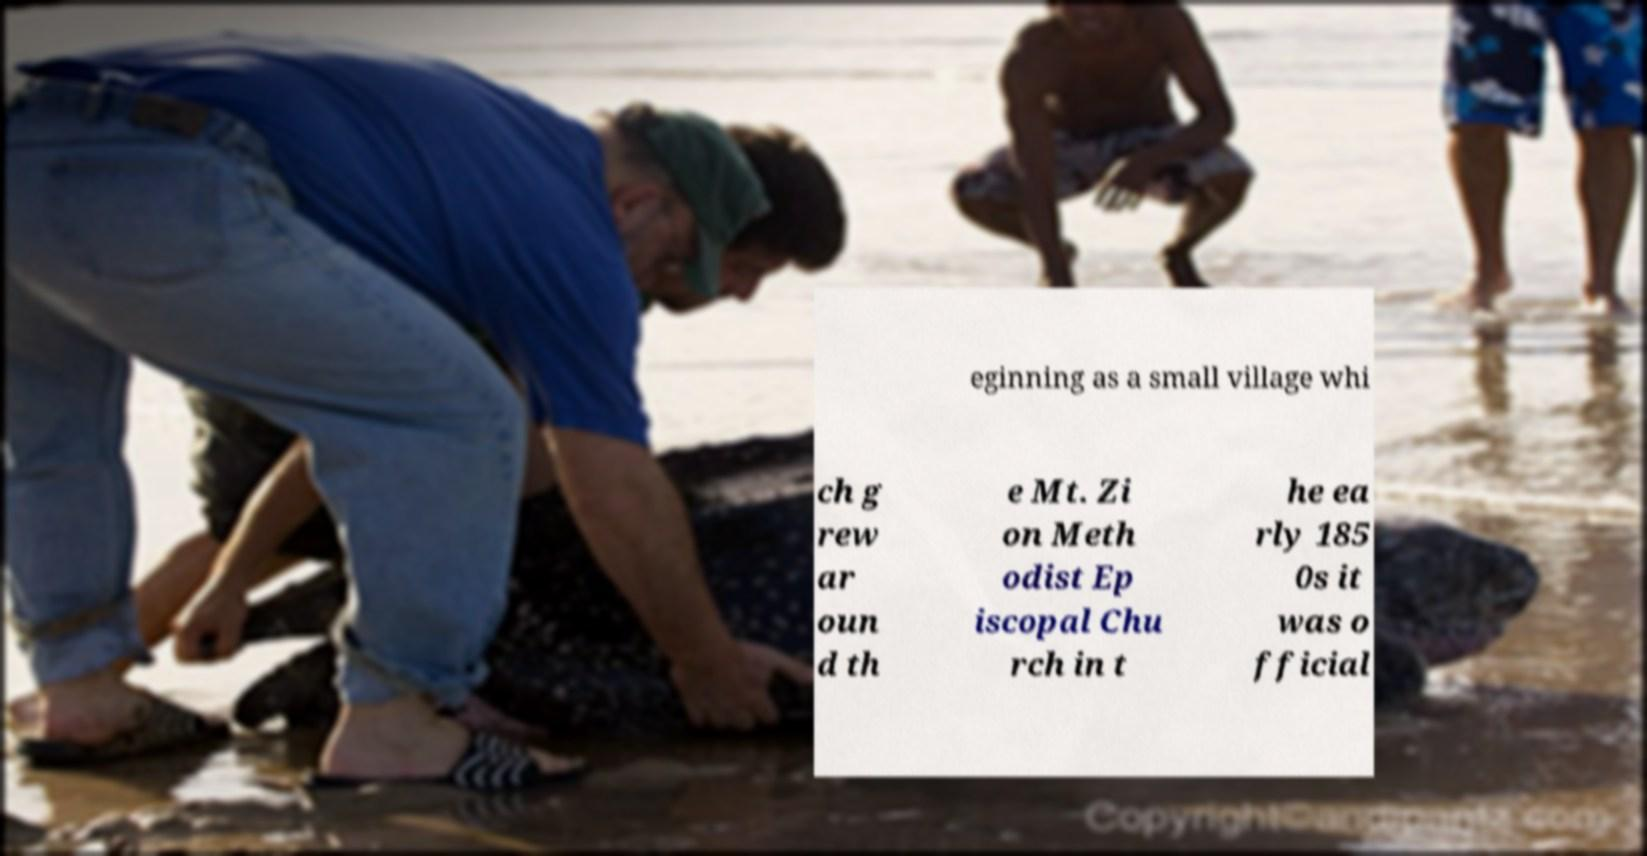Please identify and transcribe the text found in this image. eginning as a small village whi ch g rew ar oun d th e Mt. Zi on Meth odist Ep iscopal Chu rch in t he ea rly 185 0s it was o fficial 